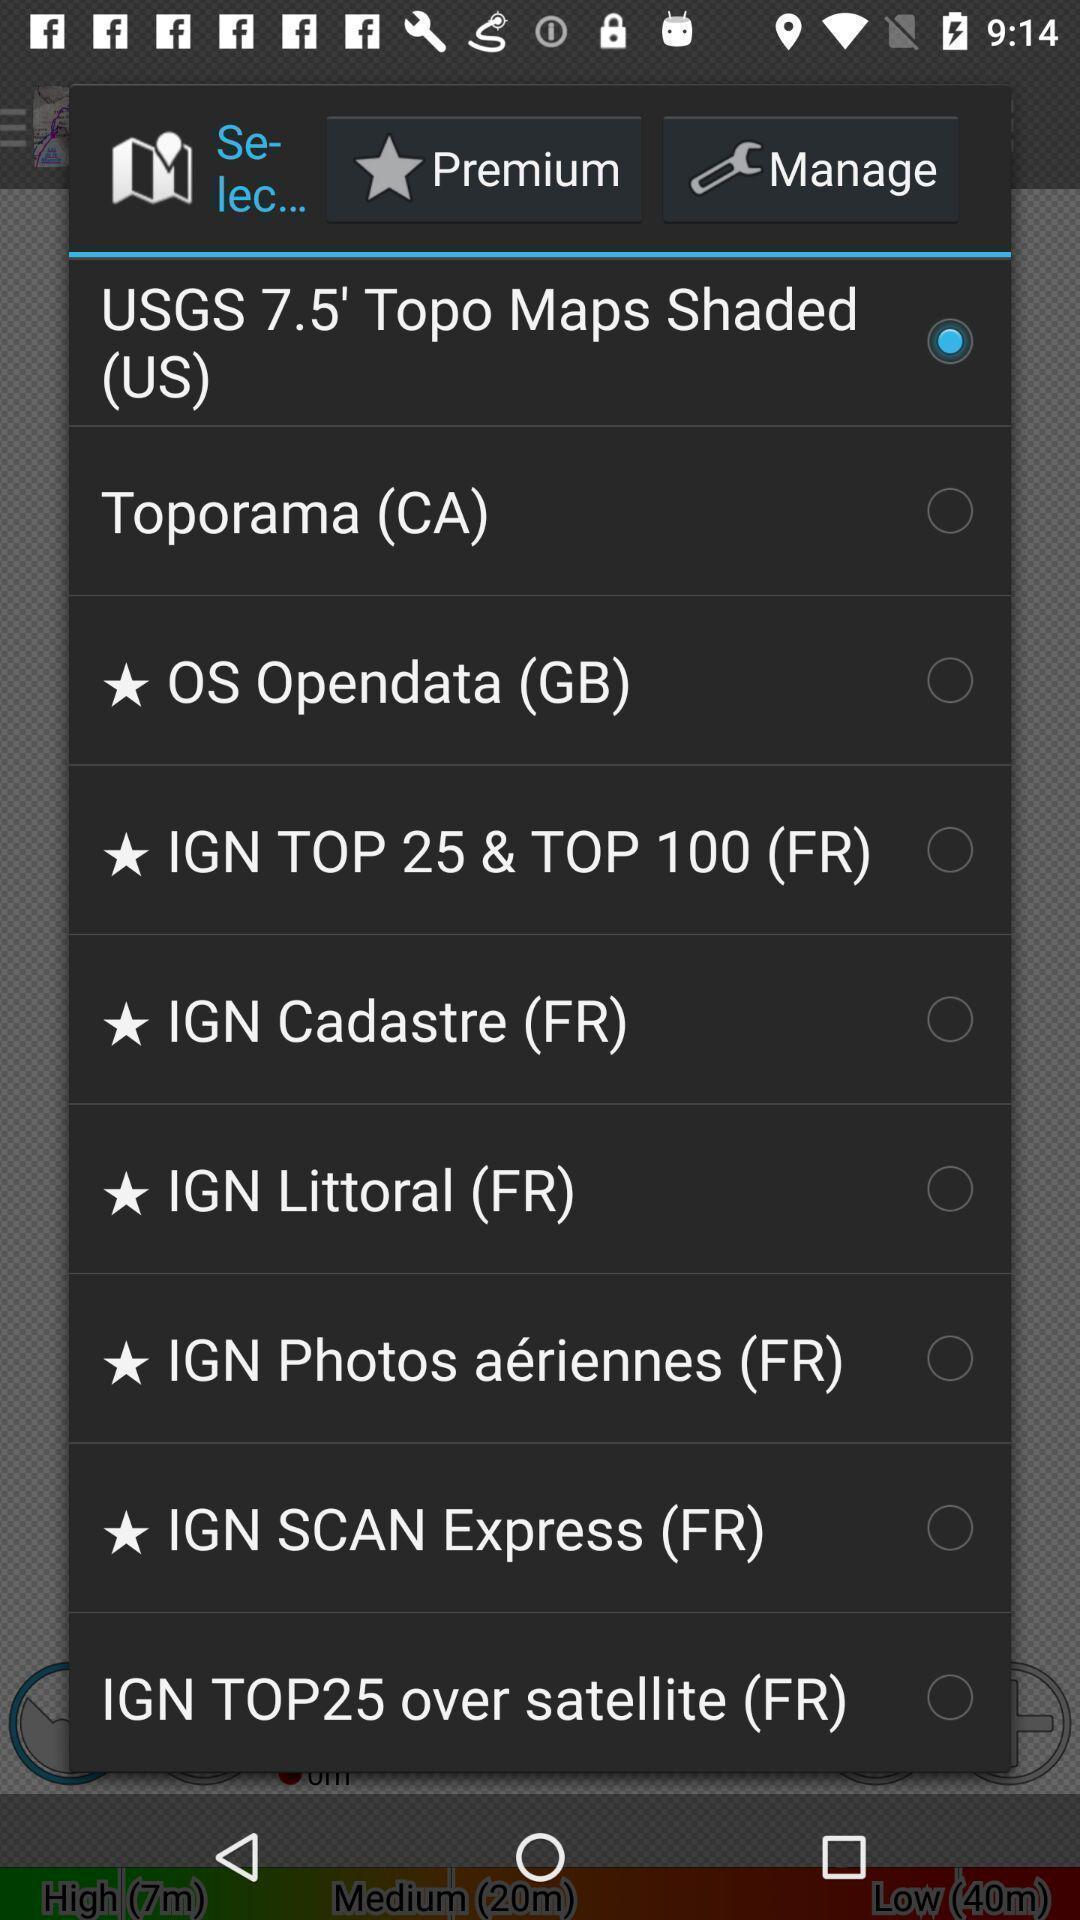Give me a narrative description of this picture. Pop-up showing list of options to select from. 